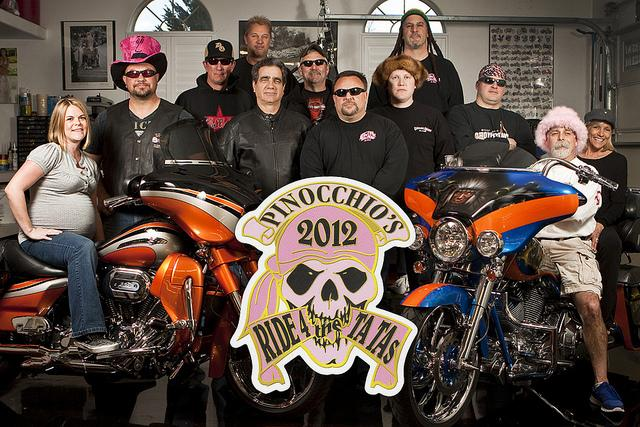What type of cancer charity are they supporting? breast 